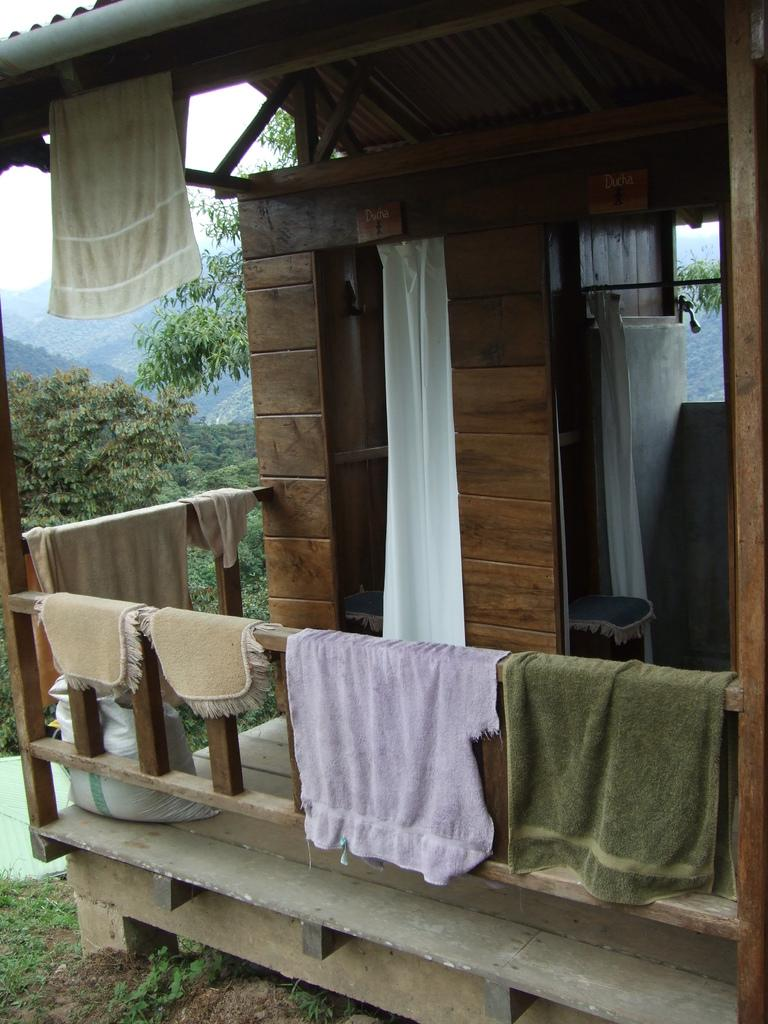What items can be seen in the image? There are clothes, a railing, a board on the wall, a bag on the floor, and plants in the image. Where is the railing located in the image? The railing is in the image. What is on the wall in the image? There is a board on the wall in the image. What is on the floor in the image? There is a bag on the floor in the image. What type of vegetation is present in the image? There are plants in the image, and trees can be seen in the background. What can be seen in the sky in the image? The sky is visible in the background of the image. Where can someone get a haircut in the image? There is no indication of a haircut or a place to get one in the image. What type of hook is hanging from the board on the wall? There is no hook present on the board in the image. 